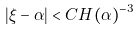Convert formula to latex. <formula><loc_0><loc_0><loc_500><loc_500>| \xi - \alpha | < C H ( \alpha ) ^ { - 3 }</formula> 